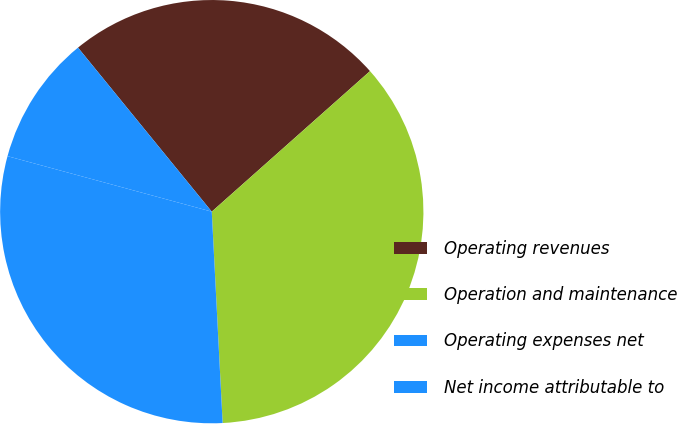Convert chart to OTSL. <chart><loc_0><loc_0><loc_500><loc_500><pie_chart><fcel>Operating revenues<fcel>Operation and maintenance<fcel>Operating expenses net<fcel>Net income attributable to<nl><fcel>24.33%<fcel>35.74%<fcel>30.04%<fcel>9.89%<nl></chart> 